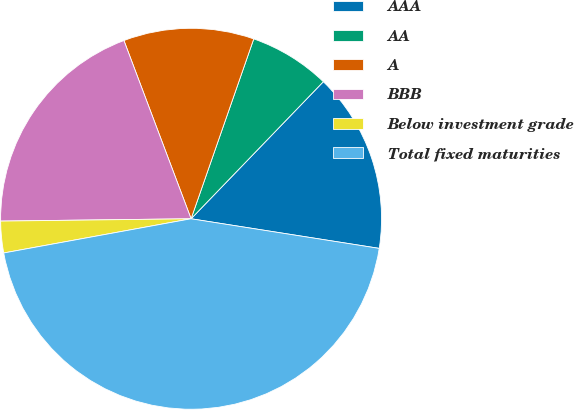Convert chart to OTSL. <chart><loc_0><loc_0><loc_500><loc_500><pie_chart><fcel>AAA<fcel>AA<fcel>A<fcel>BBB<fcel>Below investment grade<fcel>Total fixed maturities<nl><fcel>15.27%<fcel>6.88%<fcel>11.07%<fcel>19.46%<fcel>2.68%<fcel>44.64%<nl></chart> 